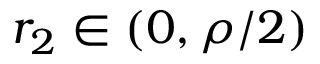Convert formula to latex. <formula><loc_0><loc_0><loc_500><loc_500>r _ { 2 } \in ( 0 , \rho / 2 )</formula> 